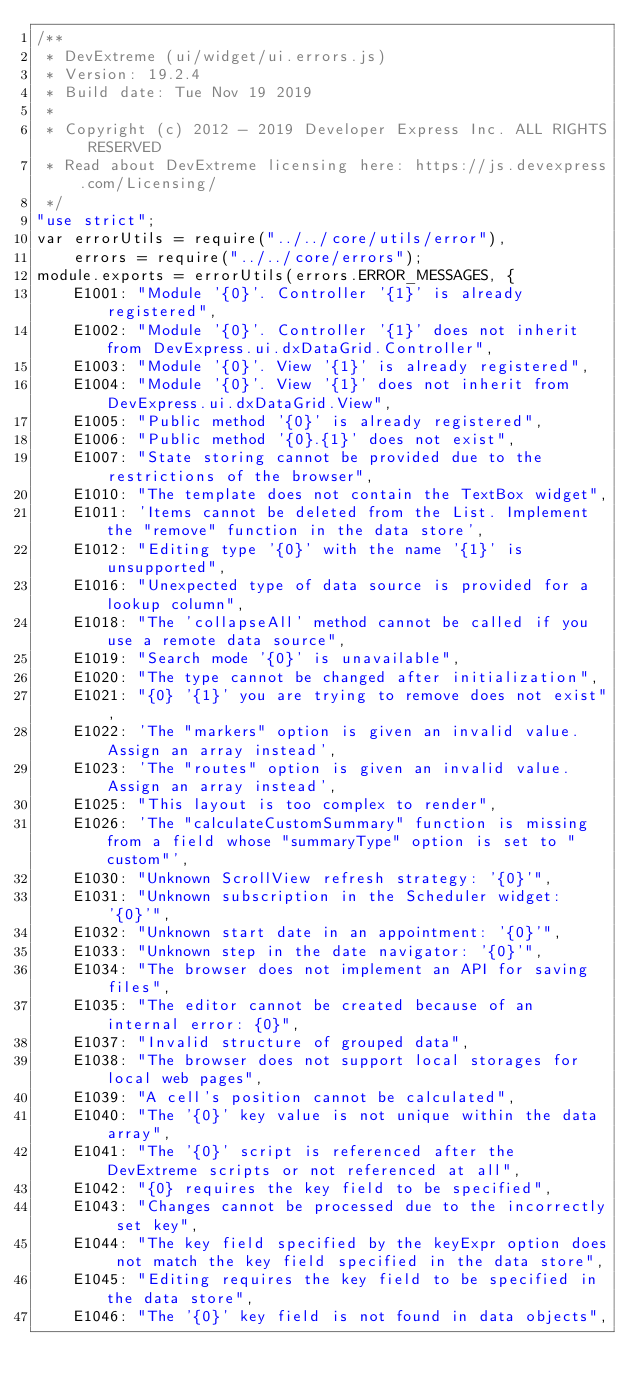<code> <loc_0><loc_0><loc_500><loc_500><_JavaScript_>/**
 * DevExtreme (ui/widget/ui.errors.js)
 * Version: 19.2.4
 * Build date: Tue Nov 19 2019
 *
 * Copyright (c) 2012 - 2019 Developer Express Inc. ALL RIGHTS RESERVED
 * Read about DevExtreme licensing here: https://js.devexpress.com/Licensing/
 */
"use strict";
var errorUtils = require("../../core/utils/error"),
    errors = require("../../core/errors");
module.exports = errorUtils(errors.ERROR_MESSAGES, {
    E1001: "Module '{0}'. Controller '{1}' is already registered",
    E1002: "Module '{0}'. Controller '{1}' does not inherit from DevExpress.ui.dxDataGrid.Controller",
    E1003: "Module '{0}'. View '{1}' is already registered",
    E1004: "Module '{0}'. View '{1}' does not inherit from DevExpress.ui.dxDataGrid.View",
    E1005: "Public method '{0}' is already registered",
    E1006: "Public method '{0}.{1}' does not exist",
    E1007: "State storing cannot be provided due to the restrictions of the browser",
    E1010: "The template does not contain the TextBox widget",
    E1011: 'Items cannot be deleted from the List. Implement the "remove" function in the data store',
    E1012: "Editing type '{0}' with the name '{1}' is unsupported",
    E1016: "Unexpected type of data source is provided for a lookup column",
    E1018: "The 'collapseAll' method cannot be called if you use a remote data source",
    E1019: "Search mode '{0}' is unavailable",
    E1020: "The type cannot be changed after initialization",
    E1021: "{0} '{1}' you are trying to remove does not exist",
    E1022: 'The "markers" option is given an invalid value. Assign an array instead',
    E1023: 'The "routes" option is given an invalid value. Assign an array instead',
    E1025: "This layout is too complex to render",
    E1026: 'The "calculateCustomSummary" function is missing from a field whose "summaryType" option is set to "custom"',
    E1030: "Unknown ScrollView refresh strategy: '{0}'",
    E1031: "Unknown subscription in the Scheduler widget: '{0}'",
    E1032: "Unknown start date in an appointment: '{0}'",
    E1033: "Unknown step in the date navigator: '{0}'",
    E1034: "The browser does not implement an API for saving files",
    E1035: "The editor cannot be created because of an internal error: {0}",
    E1037: "Invalid structure of grouped data",
    E1038: "The browser does not support local storages for local web pages",
    E1039: "A cell's position cannot be calculated",
    E1040: "The '{0}' key value is not unique within the data array",
    E1041: "The '{0}' script is referenced after the DevExtreme scripts or not referenced at all",
    E1042: "{0} requires the key field to be specified",
    E1043: "Changes cannot be processed due to the incorrectly set key",
    E1044: "The key field specified by the keyExpr option does not match the key field specified in the data store",
    E1045: "Editing requires the key field to be specified in the data store",
    E1046: "The '{0}' key field is not found in data objects",</code> 